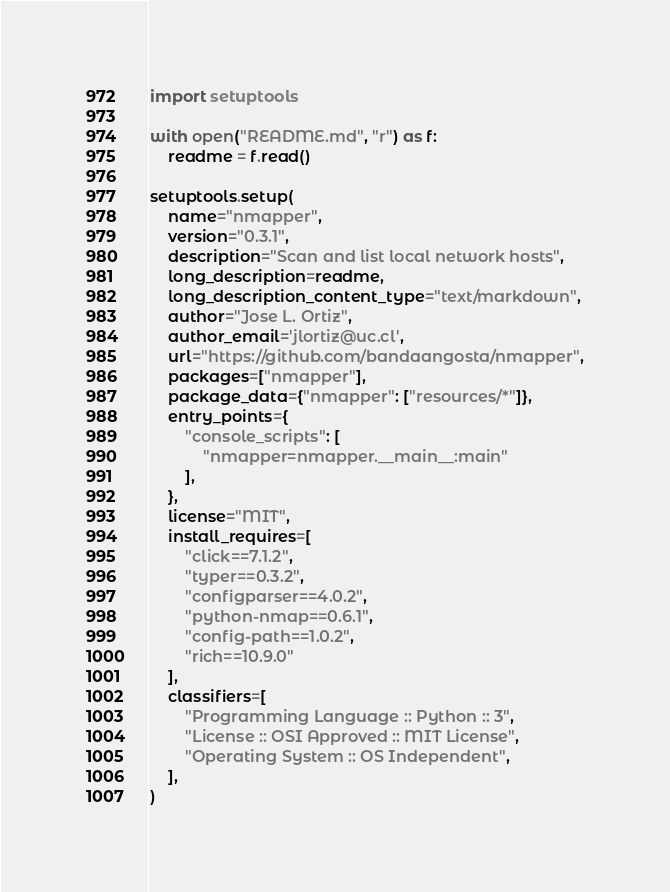Convert code to text. <code><loc_0><loc_0><loc_500><loc_500><_Python_>import setuptools

with open("README.md", "r") as f:
    readme = f.read()

setuptools.setup(
    name="nmapper",
    version="0.3.1",
    description="Scan and list local network hosts",
    long_description=readme,
    long_description_content_type="text/markdown",
    author="Jose L. Ortiz",
    author_email='jlortiz@uc.cl',
    url="https://github.com/bandaangosta/nmapper",
    packages=["nmapper"],
    package_data={"nmapper": ["resources/*"]},
    entry_points={
        "console_scripts": [
            "nmapper=nmapper.__main__:main"
        ],
    },
    license="MIT",
    install_requires=[
        "click==7.1.2",
        "typer==0.3.2",
        "configparser==4.0.2",
        "python-nmap==0.6.1",
        "config-path==1.0.2",
        "rich==10.9.0"
    ],
    classifiers=[
        "Programming Language :: Python :: 3",
        "License :: OSI Approved :: MIT License",
        "Operating System :: OS Independent",
    ],
)
</code> 